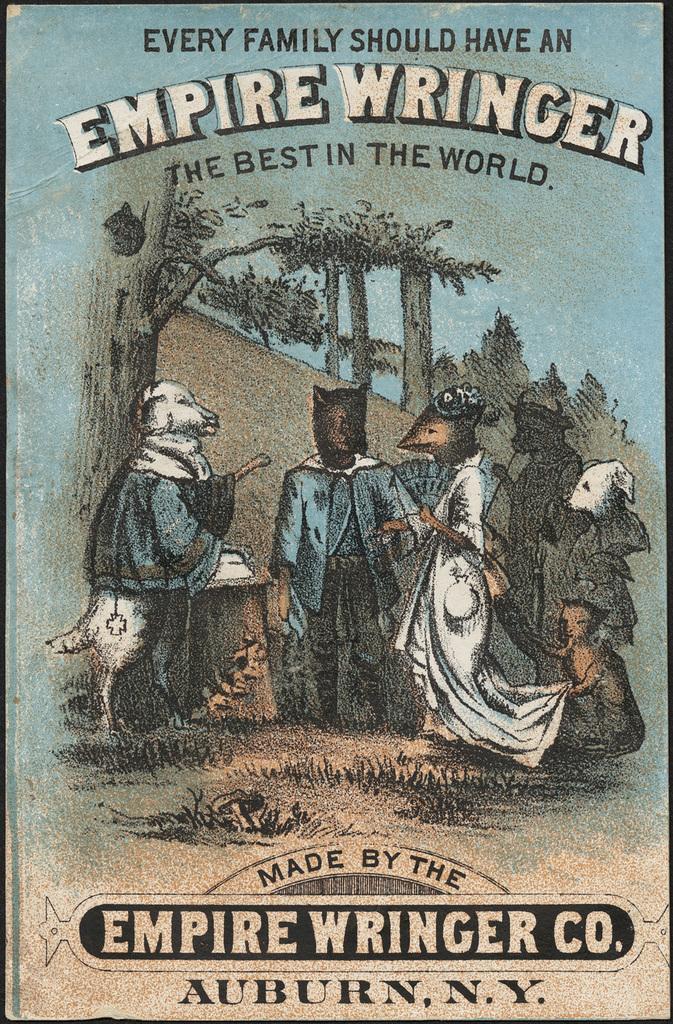How would you summarize this image in a sentence or two? In this image we can see a cover of a book. 